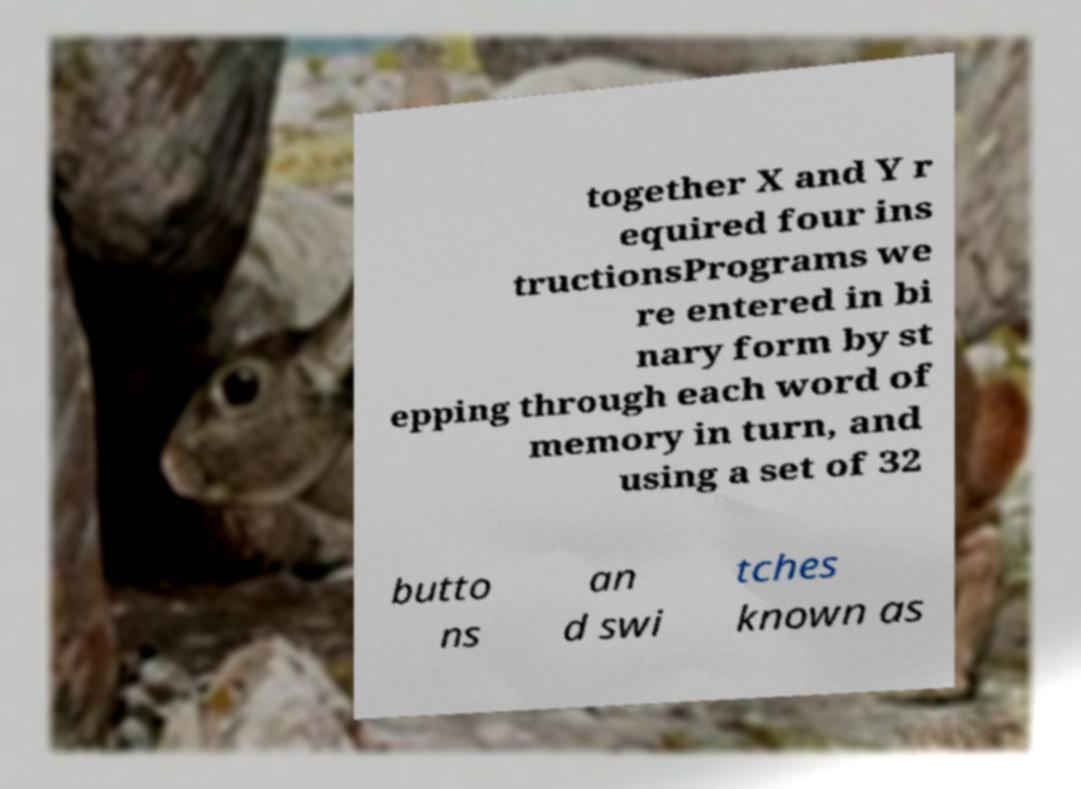Could you extract and type out the text from this image? together X and Y r equired four ins tructionsPrograms we re entered in bi nary form by st epping through each word of memory in turn, and using a set of 32 butto ns an d swi tches known as 